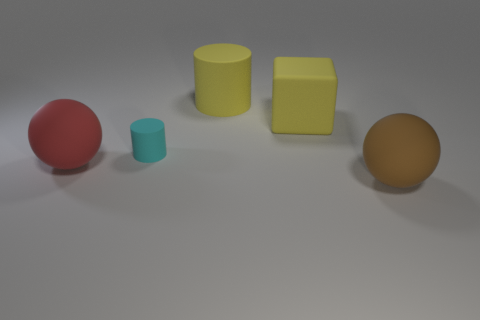Is there any other thing that is the same material as the cyan object?
Keep it short and to the point. Yes. Do the thing to the left of the small matte cylinder and the brown rubber object that is right of the small cyan object have the same shape?
Ensure brevity in your answer.  Yes. Are there fewer red spheres right of the big yellow matte cylinder than small gray matte spheres?
Offer a very short reply. No. What number of other big matte cylinders are the same color as the large cylinder?
Provide a short and direct response. 0. What is the size of the matte object behind the yellow matte cube?
Give a very brief answer. Large. There is a large thing that is to the left of the rubber cylinder that is left of the cylinder that is behind the rubber block; what is its shape?
Give a very brief answer. Sphere. The big thing that is both to the left of the yellow cube and behind the small cyan object has what shape?
Provide a short and direct response. Cylinder. Are there any cyan matte balls of the same size as the yellow matte block?
Your answer should be very brief. No. Is the shape of the yellow object that is behind the yellow rubber cube the same as  the big brown rubber object?
Offer a terse response. No. Do the big brown rubber object and the small cyan rubber object have the same shape?
Provide a succinct answer. No. 